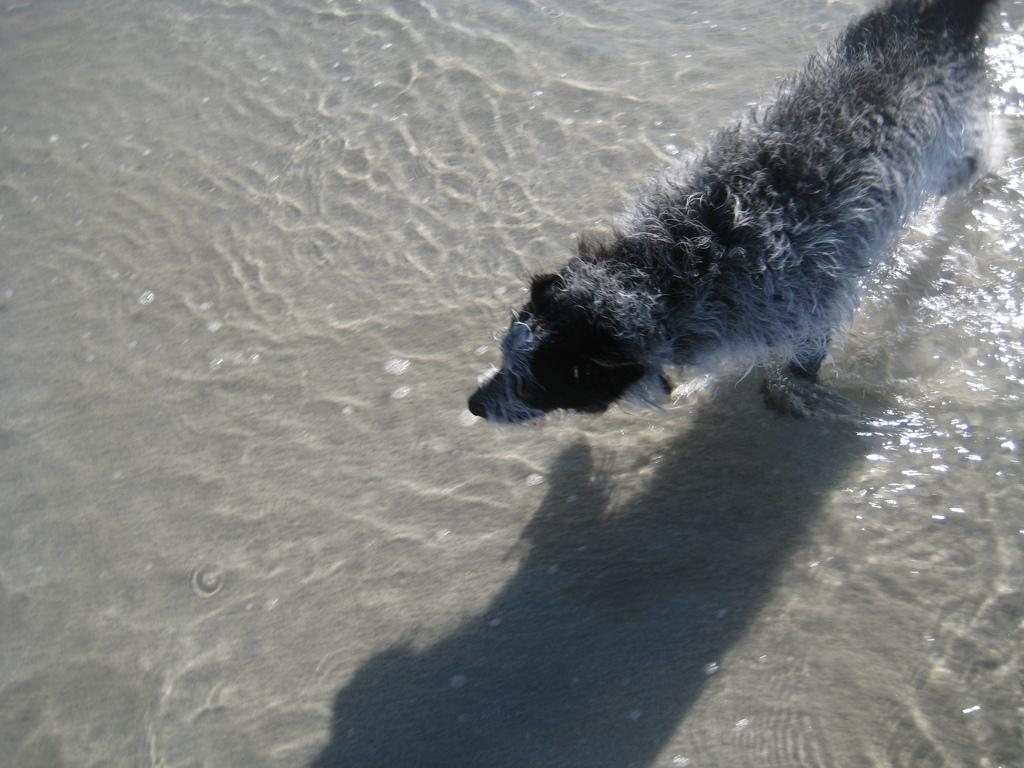What is the main subject in the foreground of the image? There is a dog in the foreground of the image. What is the dog doing in the image? The dog is walking in the water. Can you describe any additional details about the dog in the image? The dog's shadow is visible in the image. What type of butter is being used to feed the cattle in the image? There are no cattle or butter present in the image; it features a dog walking in the water. 